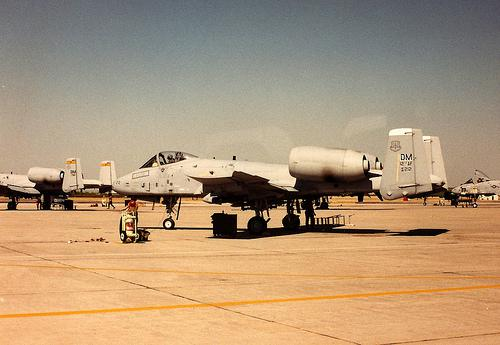Question: how many planes are there?
Choices:
A. Two.
B. More than one.
C. Three.
D. Four.
Answer with the letter. Answer: B Question: where is the plane's wheels?
Choices:
A. On the pavement.
B. In the air.
C. Under the plane.
D. Tucked in the planes belly.
Answer with the letter. Answer: C Question: what is the color of the plane?
Choices:
A. White.
B. Blue.
C. Red.
D. Gray.
Answer with the letter. Answer: D Question: when will the plane leave?
Choices:
A. Once the pilot is ready.
B. Late tonight.
C. In the morning.
D. In one hour.
Answer with the letter. Answer: A 